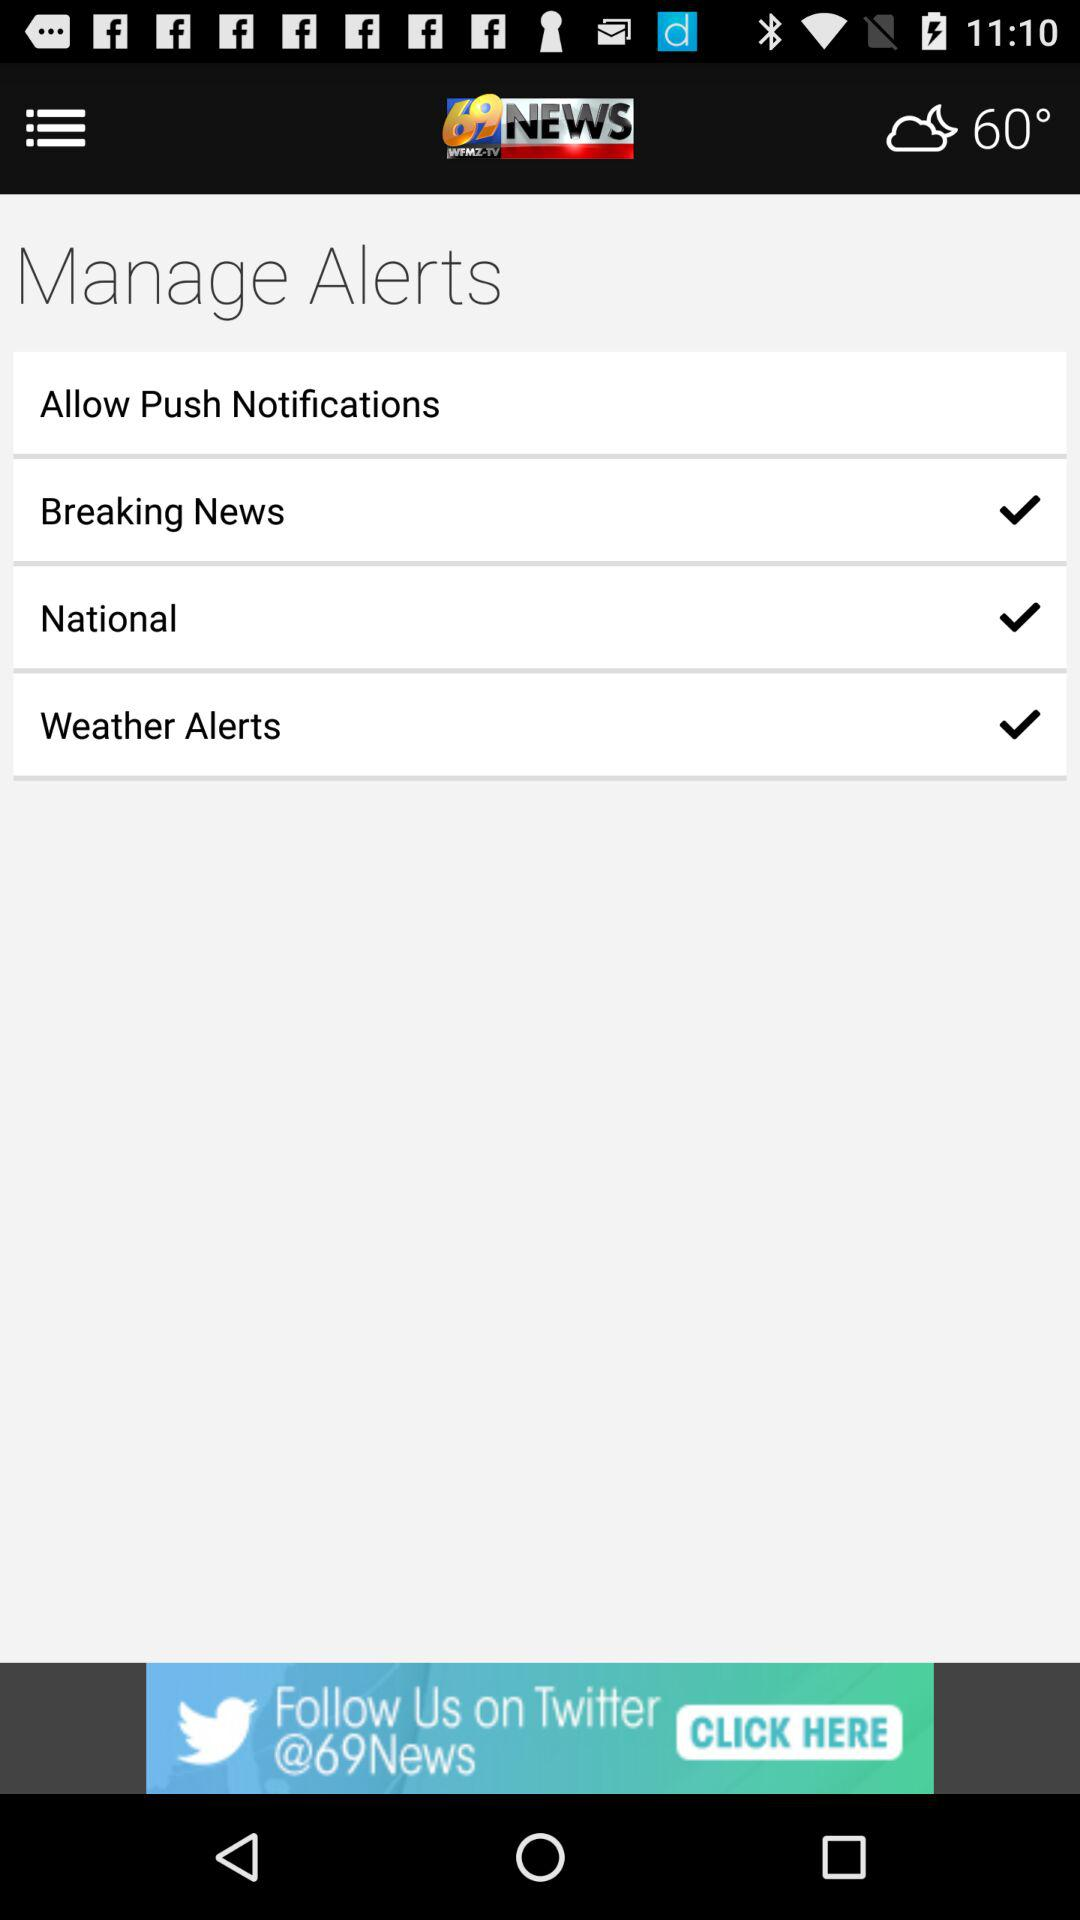What is the location?
When the provided information is insufficient, respond with <no answer>. <no answer> 